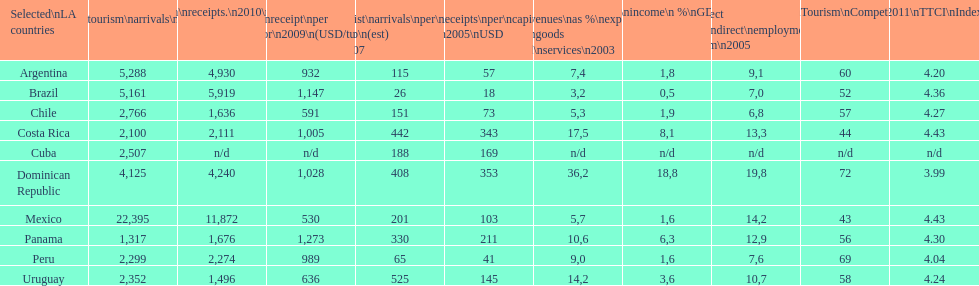Which country had the least amount of tourism income in 2003? Brazil. 